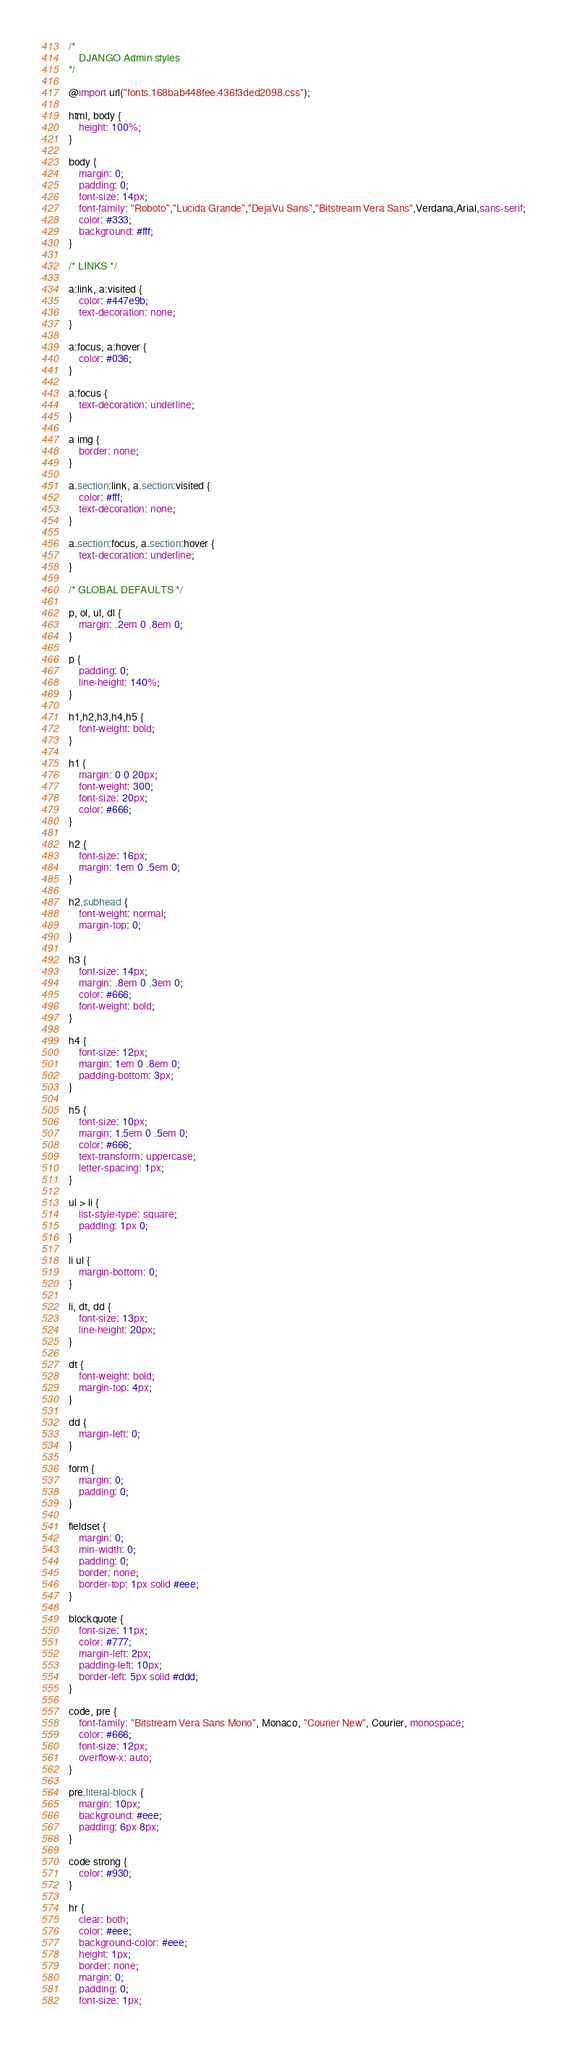<code> <loc_0><loc_0><loc_500><loc_500><_CSS_>/*
    DJANGO Admin styles
*/

@import url("fonts.168bab448fee.436f3ded2098.css");

html, body {
    height: 100%;
}

body {
    margin: 0;
    padding: 0;
    font-size: 14px;
    font-family: "Roboto","Lucida Grande","DejaVu Sans","Bitstream Vera Sans",Verdana,Arial,sans-serif;
    color: #333;
    background: #fff;
}

/* LINKS */

a:link, a:visited {
    color: #447e9b;
    text-decoration: none;
}

a:focus, a:hover {
    color: #036;
}

a:focus {
    text-decoration: underline;
}

a img {
    border: none;
}

a.section:link, a.section:visited {
    color: #fff;
    text-decoration: none;
}

a.section:focus, a.section:hover {
    text-decoration: underline;
}

/* GLOBAL DEFAULTS */

p, ol, ul, dl {
    margin: .2em 0 .8em 0;
}

p {
    padding: 0;
    line-height: 140%;
}

h1,h2,h3,h4,h5 {
    font-weight: bold;
}

h1 {
    margin: 0 0 20px;
    font-weight: 300;
    font-size: 20px;
    color: #666;
}

h2 {
    font-size: 16px;
    margin: 1em 0 .5em 0;
}

h2.subhead {
    font-weight: normal;
    margin-top: 0;
}

h3 {
    font-size: 14px;
    margin: .8em 0 .3em 0;
    color: #666;
    font-weight: bold;
}

h4 {
    font-size: 12px;
    margin: 1em 0 .8em 0;
    padding-bottom: 3px;
}

h5 {
    font-size: 10px;
    margin: 1.5em 0 .5em 0;
    color: #666;
    text-transform: uppercase;
    letter-spacing: 1px;
}

ul > li {
    list-style-type: square;
    padding: 1px 0;
}

li ul {
    margin-bottom: 0;
}

li, dt, dd {
    font-size: 13px;
    line-height: 20px;
}

dt {
    font-weight: bold;
    margin-top: 4px;
}

dd {
    margin-left: 0;
}

form {
    margin: 0;
    padding: 0;
}

fieldset {
    margin: 0;
    min-width: 0;
    padding: 0;
    border: none;
    border-top: 1px solid #eee;
}

blockquote {
    font-size: 11px;
    color: #777;
    margin-left: 2px;
    padding-left: 10px;
    border-left: 5px solid #ddd;
}

code, pre {
    font-family: "Bitstream Vera Sans Mono", Monaco, "Courier New", Courier, monospace;
    color: #666;
    font-size: 12px;
    overflow-x: auto;
}

pre.literal-block {
    margin: 10px;
    background: #eee;
    padding: 6px 8px;
}

code strong {
    color: #930;
}

hr {
    clear: both;
    color: #eee;
    background-color: #eee;
    height: 1px;
    border: none;
    margin: 0;
    padding: 0;
    font-size: 1px;</code> 